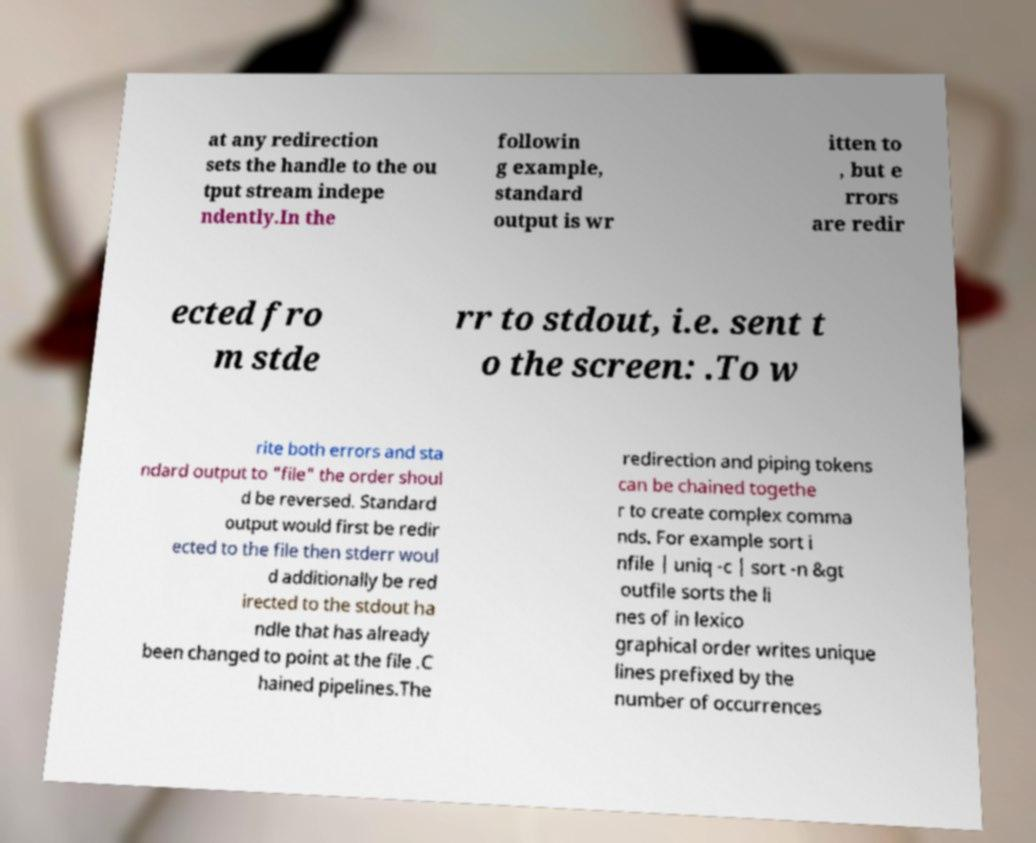There's text embedded in this image that I need extracted. Can you transcribe it verbatim? at any redirection sets the handle to the ou tput stream indepe ndently.In the followin g example, standard output is wr itten to , but e rrors are redir ected fro m stde rr to stdout, i.e. sent t o the screen: .To w rite both errors and sta ndard output to "file" the order shoul d be reversed. Standard output would first be redir ected to the file then stderr woul d additionally be red irected to the stdout ha ndle that has already been changed to point at the file .C hained pipelines.The redirection and piping tokens can be chained togethe r to create complex comma nds. For example sort i nfile | uniq -c | sort -n &gt outfile sorts the li nes of in lexico graphical order writes unique lines prefixed by the number of occurrences 